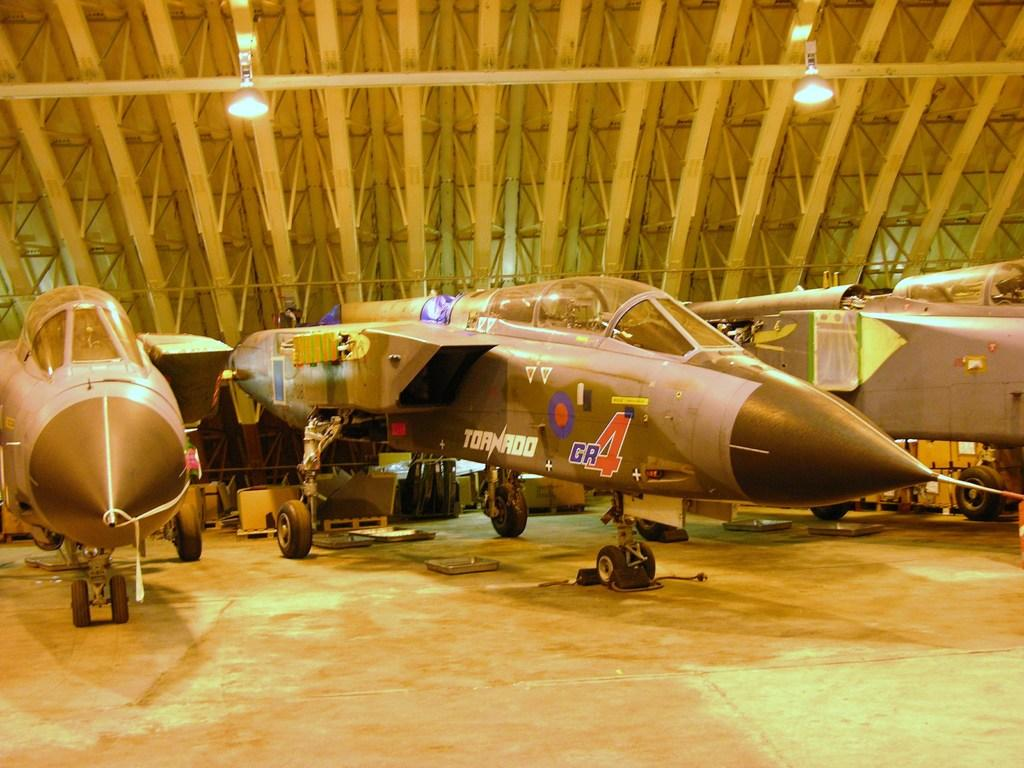<image>
Present a compact description of the photo's key features. A plane in a hangar with the name Tornado on it between two similar planes 